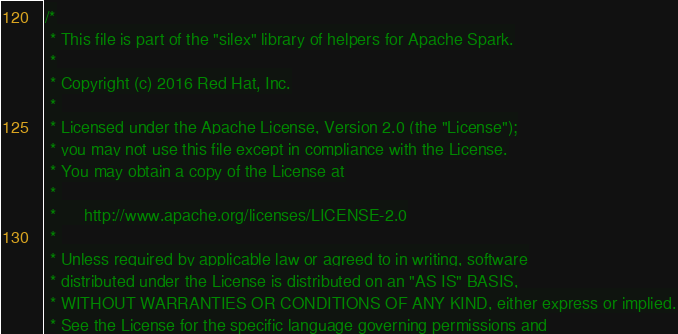Convert code to text. <code><loc_0><loc_0><loc_500><loc_500><_Scala_>/*
 * This file is part of the "silex" library of helpers for Apache Spark.
 *
 * Copyright (c) 2016 Red Hat, Inc.
 * 
 * Licensed under the Apache License, Version 2.0 (the "License");
 * you may not use this file except in compliance with the License.
 * You may obtain a copy of the License at
 * 
 *      http://www.apache.org/licenses/LICENSE-2.0
 * 
 * Unless required by applicable law or agreed to in writing, software
 * distributed under the License is distributed on an "AS IS" BASIS,
 * WITHOUT WARRANTIES OR CONDITIONS OF ANY KIND, either express or implied.
 * See the License for the specific language governing permissions and</code> 